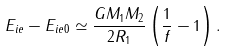Convert formula to latex. <formula><loc_0><loc_0><loc_500><loc_500>E _ { i e } - E _ { i e 0 } \simeq \frac { G M _ { 1 } M _ { 2 } } { 2 R _ { 1 } } \left ( \frac { 1 } { f } - 1 \right ) .</formula> 